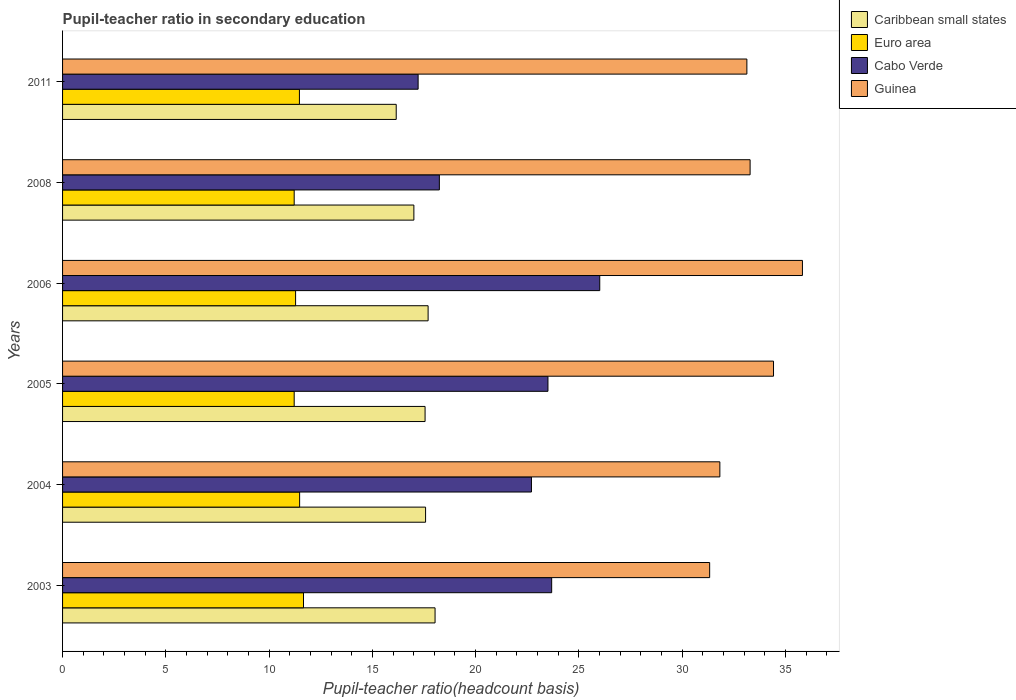How many different coloured bars are there?
Your answer should be very brief. 4. Are the number of bars on each tick of the Y-axis equal?
Make the answer very short. Yes. How many bars are there on the 1st tick from the top?
Offer a very short reply. 4. What is the pupil-teacher ratio in secondary education in Euro area in 2004?
Make the answer very short. 11.48. Across all years, what is the maximum pupil-teacher ratio in secondary education in Caribbean small states?
Offer a very short reply. 18.04. Across all years, what is the minimum pupil-teacher ratio in secondary education in Cabo Verde?
Ensure brevity in your answer.  17.22. In which year was the pupil-teacher ratio in secondary education in Guinea minimum?
Provide a short and direct response. 2003. What is the total pupil-teacher ratio in secondary education in Caribbean small states in the graph?
Your answer should be very brief. 104.04. What is the difference between the pupil-teacher ratio in secondary education in Guinea in 2003 and that in 2008?
Your response must be concise. -1.96. What is the difference between the pupil-teacher ratio in secondary education in Caribbean small states in 2005 and the pupil-teacher ratio in secondary education in Guinea in 2008?
Offer a terse response. -15.74. What is the average pupil-teacher ratio in secondary education in Guinea per year?
Provide a succinct answer. 33.31. In the year 2011, what is the difference between the pupil-teacher ratio in secondary education in Euro area and pupil-teacher ratio in secondary education in Guinea?
Give a very brief answer. -21.67. In how many years, is the pupil-teacher ratio in secondary education in Caribbean small states greater than 5 ?
Offer a terse response. 6. What is the ratio of the pupil-teacher ratio in secondary education in Guinea in 2003 to that in 2006?
Ensure brevity in your answer.  0.87. What is the difference between the highest and the second highest pupil-teacher ratio in secondary education in Euro area?
Your answer should be compact. 0.19. What is the difference between the highest and the lowest pupil-teacher ratio in secondary education in Guinea?
Make the answer very short. 4.49. In how many years, is the pupil-teacher ratio in secondary education in Guinea greater than the average pupil-teacher ratio in secondary education in Guinea taken over all years?
Provide a short and direct response. 2. Is the sum of the pupil-teacher ratio in secondary education in Guinea in 2003 and 2011 greater than the maximum pupil-teacher ratio in secondary education in Euro area across all years?
Your answer should be compact. Yes. What does the 4th bar from the top in 2011 represents?
Provide a succinct answer. Caribbean small states. What does the 3rd bar from the bottom in 2005 represents?
Provide a succinct answer. Cabo Verde. What is the difference between two consecutive major ticks on the X-axis?
Give a very brief answer. 5. Does the graph contain any zero values?
Provide a succinct answer. No. Where does the legend appear in the graph?
Give a very brief answer. Top right. What is the title of the graph?
Your answer should be compact. Pupil-teacher ratio in secondary education. What is the label or title of the X-axis?
Your answer should be very brief. Pupil-teacher ratio(headcount basis). What is the label or title of the Y-axis?
Offer a very short reply. Years. What is the Pupil-teacher ratio(headcount basis) in Caribbean small states in 2003?
Offer a very short reply. 18.04. What is the Pupil-teacher ratio(headcount basis) in Euro area in 2003?
Provide a succinct answer. 11.67. What is the Pupil-teacher ratio(headcount basis) of Cabo Verde in 2003?
Your answer should be very brief. 23.68. What is the Pupil-teacher ratio(headcount basis) in Guinea in 2003?
Give a very brief answer. 31.33. What is the Pupil-teacher ratio(headcount basis) of Caribbean small states in 2004?
Provide a succinct answer. 17.58. What is the Pupil-teacher ratio(headcount basis) of Euro area in 2004?
Make the answer very short. 11.48. What is the Pupil-teacher ratio(headcount basis) in Cabo Verde in 2004?
Keep it short and to the point. 22.7. What is the Pupil-teacher ratio(headcount basis) in Guinea in 2004?
Your answer should be compact. 31.83. What is the Pupil-teacher ratio(headcount basis) of Caribbean small states in 2005?
Your answer should be compact. 17.55. What is the Pupil-teacher ratio(headcount basis) of Euro area in 2005?
Your response must be concise. 11.22. What is the Pupil-teacher ratio(headcount basis) of Cabo Verde in 2005?
Your response must be concise. 23.5. What is the Pupil-teacher ratio(headcount basis) of Guinea in 2005?
Provide a succinct answer. 34.43. What is the Pupil-teacher ratio(headcount basis) in Caribbean small states in 2006?
Ensure brevity in your answer.  17.7. What is the Pupil-teacher ratio(headcount basis) of Euro area in 2006?
Keep it short and to the point. 11.28. What is the Pupil-teacher ratio(headcount basis) in Cabo Verde in 2006?
Your response must be concise. 26.01. What is the Pupil-teacher ratio(headcount basis) in Guinea in 2006?
Give a very brief answer. 35.83. What is the Pupil-teacher ratio(headcount basis) of Caribbean small states in 2008?
Your response must be concise. 17.01. What is the Pupil-teacher ratio(headcount basis) of Euro area in 2008?
Give a very brief answer. 11.22. What is the Pupil-teacher ratio(headcount basis) of Cabo Verde in 2008?
Keep it short and to the point. 18.25. What is the Pupil-teacher ratio(headcount basis) in Guinea in 2008?
Your answer should be very brief. 33.29. What is the Pupil-teacher ratio(headcount basis) in Caribbean small states in 2011?
Your response must be concise. 16.16. What is the Pupil-teacher ratio(headcount basis) of Euro area in 2011?
Provide a succinct answer. 11.47. What is the Pupil-teacher ratio(headcount basis) in Cabo Verde in 2011?
Make the answer very short. 17.22. What is the Pupil-teacher ratio(headcount basis) of Guinea in 2011?
Provide a succinct answer. 33.14. Across all years, what is the maximum Pupil-teacher ratio(headcount basis) of Caribbean small states?
Keep it short and to the point. 18.04. Across all years, what is the maximum Pupil-teacher ratio(headcount basis) of Euro area?
Keep it short and to the point. 11.67. Across all years, what is the maximum Pupil-teacher ratio(headcount basis) of Cabo Verde?
Provide a succinct answer. 26.01. Across all years, what is the maximum Pupil-teacher ratio(headcount basis) in Guinea?
Offer a terse response. 35.83. Across all years, what is the minimum Pupil-teacher ratio(headcount basis) of Caribbean small states?
Provide a succinct answer. 16.16. Across all years, what is the minimum Pupil-teacher ratio(headcount basis) in Euro area?
Offer a terse response. 11.22. Across all years, what is the minimum Pupil-teacher ratio(headcount basis) of Cabo Verde?
Make the answer very short. 17.22. Across all years, what is the minimum Pupil-teacher ratio(headcount basis) of Guinea?
Provide a succinct answer. 31.33. What is the total Pupil-teacher ratio(headcount basis) of Caribbean small states in the graph?
Your response must be concise. 104.04. What is the total Pupil-teacher ratio(headcount basis) of Euro area in the graph?
Keep it short and to the point. 68.33. What is the total Pupil-teacher ratio(headcount basis) in Cabo Verde in the graph?
Your response must be concise. 131.36. What is the total Pupil-teacher ratio(headcount basis) of Guinea in the graph?
Provide a short and direct response. 199.84. What is the difference between the Pupil-teacher ratio(headcount basis) in Caribbean small states in 2003 and that in 2004?
Keep it short and to the point. 0.46. What is the difference between the Pupil-teacher ratio(headcount basis) in Euro area in 2003 and that in 2004?
Make the answer very short. 0.19. What is the difference between the Pupil-teacher ratio(headcount basis) in Cabo Verde in 2003 and that in 2004?
Provide a short and direct response. 0.98. What is the difference between the Pupil-teacher ratio(headcount basis) of Guinea in 2003 and that in 2004?
Provide a succinct answer. -0.49. What is the difference between the Pupil-teacher ratio(headcount basis) in Caribbean small states in 2003 and that in 2005?
Provide a short and direct response. 0.48. What is the difference between the Pupil-teacher ratio(headcount basis) in Euro area in 2003 and that in 2005?
Make the answer very short. 0.45. What is the difference between the Pupil-teacher ratio(headcount basis) of Cabo Verde in 2003 and that in 2005?
Make the answer very short. 0.18. What is the difference between the Pupil-teacher ratio(headcount basis) of Guinea in 2003 and that in 2005?
Your answer should be very brief. -3.09. What is the difference between the Pupil-teacher ratio(headcount basis) in Caribbean small states in 2003 and that in 2006?
Offer a terse response. 0.34. What is the difference between the Pupil-teacher ratio(headcount basis) in Euro area in 2003 and that in 2006?
Make the answer very short. 0.38. What is the difference between the Pupil-teacher ratio(headcount basis) of Cabo Verde in 2003 and that in 2006?
Offer a very short reply. -2.33. What is the difference between the Pupil-teacher ratio(headcount basis) in Guinea in 2003 and that in 2006?
Ensure brevity in your answer.  -4.49. What is the difference between the Pupil-teacher ratio(headcount basis) of Caribbean small states in 2003 and that in 2008?
Provide a succinct answer. 1.03. What is the difference between the Pupil-teacher ratio(headcount basis) in Euro area in 2003 and that in 2008?
Provide a short and direct response. 0.45. What is the difference between the Pupil-teacher ratio(headcount basis) of Cabo Verde in 2003 and that in 2008?
Provide a short and direct response. 5.44. What is the difference between the Pupil-teacher ratio(headcount basis) of Guinea in 2003 and that in 2008?
Your answer should be compact. -1.96. What is the difference between the Pupil-teacher ratio(headcount basis) of Caribbean small states in 2003 and that in 2011?
Your answer should be very brief. 1.88. What is the difference between the Pupil-teacher ratio(headcount basis) in Euro area in 2003 and that in 2011?
Make the answer very short. 0.2. What is the difference between the Pupil-teacher ratio(headcount basis) of Cabo Verde in 2003 and that in 2011?
Provide a short and direct response. 6.47. What is the difference between the Pupil-teacher ratio(headcount basis) in Guinea in 2003 and that in 2011?
Your response must be concise. -1.8. What is the difference between the Pupil-teacher ratio(headcount basis) of Caribbean small states in 2004 and that in 2005?
Provide a short and direct response. 0.02. What is the difference between the Pupil-teacher ratio(headcount basis) in Euro area in 2004 and that in 2005?
Make the answer very short. 0.26. What is the difference between the Pupil-teacher ratio(headcount basis) in Cabo Verde in 2004 and that in 2005?
Provide a short and direct response. -0.8. What is the difference between the Pupil-teacher ratio(headcount basis) in Guinea in 2004 and that in 2005?
Provide a succinct answer. -2.6. What is the difference between the Pupil-teacher ratio(headcount basis) in Caribbean small states in 2004 and that in 2006?
Your response must be concise. -0.12. What is the difference between the Pupil-teacher ratio(headcount basis) of Euro area in 2004 and that in 2006?
Provide a short and direct response. 0.2. What is the difference between the Pupil-teacher ratio(headcount basis) of Cabo Verde in 2004 and that in 2006?
Provide a succinct answer. -3.31. What is the difference between the Pupil-teacher ratio(headcount basis) of Guinea in 2004 and that in 2006?
Offer a very short reply. -4. What is the difference between the Pupil-teacher ratio(headcount basis) of Caribbean small states in 2004 and that in 2008?
Your response must be concise. 0.57. What is the difference between the Pupil-teacher ratio(headcount basis) in Euro area in 2004 and that in 2008?
Ensure brevity in your answer.  0.26. What is the difference between the Pupil-teacher ratio(headcount basis) in Cabo Verde in 2004 and that in 2008?
Your response must be concise. 4.46. What is the difference between the Pupil-teacher ratio(headcount basis) of Guinea in 2004 and that in 2008?
Make the answer very short. -1.46. What is the difference between the Pupil-teacher ratio(headcount basis) of Caribbean small states in 2004 and that in 2011?
Give a very brief answer. 1.42. What is the difference between the Pupil-teacher ratio(headcount basis) in Euro area in 2004 and that in 2011?
Give a very brief answer. 0.01. What is the difference between the Pupil-teacher ratio(headcount basis) in Cabo Verde in 2004 and that in 2011?
Offer a terse response. 5.49. What is the difference between the Pupil-teacher ratio(headcount basis) in Guinea in 2004 and that in 2011?
Your answer should be very brief. -1.31. What is the difference between the Pupil-teacher ratio(headcount basis) of Caribbean small states in 2005 and that in 2006?
Ensure brevity in your answer.  -0.15. What is the difference between the Pupil-teacher ratio(headcount basis) of Euro area in 2005 and that in 2006?
Your answer should be compact. -0.07. What is the difference between the Pupil-teacher ratio(headcount basis) of Cabo Verde in 2005 and that in 2006?
Your response must be concise. -2.51. What is the difference between the Pupil-teacher ratio(headcount basis) in Guinea in 2005 and that in 2006?
Provide a short and direct response. -1.4. What is the difference between the Pupil-teacher ratio(headcount basis) in Caribbean small states in 2005 and that in 2008?
Make the answer very short. 0.54. What is the difference between the Pupil-teacher ratio(headcount basis) in Euro area in 2005 and that in 2008?
Your answer should be compact. 0. What is the difference between the Pupil-teacher ratio(headcount basis) of Cabo Verde in 2005 and that in 2008?
Keep it short and to the point. 5.26. What is the difference between the Pupil-teacher ratio(headcount basis) in Guinea in 2005 and that in 2008?
Ensure brevity in your answer.  1.13. What is the difference between the Pupil-teacher ratio(headcount basis) in Caribbean small states in 2005 and that in 2011?
Your answer should be very brief. 1.4. What is the difference between the Pupil-teacher ratio(headcount basis) of Euro area in 2005 and that in 2011?
Your response must be concise. -0.25. What is the difference between the Pupil-teacher ratio(headcount basis) of Cabo Verde in 2005 and that in 2011?
Offer a very short reply. 6.29. What is the difference between the Pupil-teacher ratio(headcount basis) in Guinea in 2005 and that in 2011?
Your answer should be very brief. 1.29. What is the difference between the Pupil-teacher ratio(headcount basis) of Caribbean small states in 2006 and that in 2008?
Offer a very short reply. 0.69. What is the difference between the Pupil-teacher ratio(headcount basis) of Euro area in 2006 and that in 2008?
Your response must be concise. 0.07. What is the difference between the Pupil-teacher ratio(headcount basis) of Cabo Verde in 2006 and that in 2008?
Give a very brief answer. 7.77. What is the difference between the Pupil-teacher ratio(headcount basis) in Guinea in 2006 and that in 2008?
Provide a succinct answer. 2.53. What is the difference between the Pupil-teacher ratio(headcount basis) in Caribbean small states in 2006 and that in 2011?
Provide a succinct answer. 1.54. What is the difference between the Pupil-teacher ratio(headcount basis) in Euro area in 2006 and that in 2011?
Keep it short and to the point. -0.19. What is the difference between the Pupil-teacher ratio(headcount basis) of Cabo Verde in 2006 and that in 2011?
Make the answer very short. 8.79. What is the difference between the Pupil-teacher ratio(headcount basis) in Guinea in 2006 and that in 2011?
Your answer should be compact. 2.69. What is the difference between the Pupil-teacher ratio(headcount basis) of Caribbean small states in 2008 and that in 2011?
Provide a short and direct response. 0.86. What is the difference between the Pupil-teacher ratio(headcount basis) in Euro area in 2008 and that in 2011?
Give a very brief answer. -0.25. What is the difference between the Pupil-teacher ratio(headcount basis) in Cabo Verde in 2008 and that in 2011?
Keep it short and to the point. 1.03. What is the difference between the Pupil-teacher ratio(headcount basis) in Guinea in 2008 and that in 2011?
Make the answer very short. 0.16. What is the difference between the Pupil-teacher ratio(headcount basis) of Caribbean small states in 2003 and the Pupil-teacher ratio(headcount basis) of Euro area in 2004?
Ensure brevity in your answer.  6.56. What is the difference between the Pupil-teacher ratio(headcount basis) of Caribbean small states in 2003 and the Pupil-teacher ratio(headcount basis) of Cabo Verde in 2004?
Ensure brevity in your answer.  -4.67. What is the difference between the Pupil-teacher ratio(headcount basis) of Caribbean small states in 2003 and the Pupil-teacher ratio(headcount basis) of Guinea in 2004?
Provide a short and direct response. -13.79. What is the difference between the Pupil-teacher ratio(headcount basis) in Euro area in 2003 and the Pupil-teacher ratio(headcount basis) in Cabo Verde in 2004?
Give a very brief answer. -11.04. What is the difference between the Pupil-teacher ratio(headcount basis) of Euro area in 2003 and the Pupil-teacher ratio(headcount basis) of Guinea in 2004?
Provide a succinct answer. -20.16. What is the difference between the Pupil-teacher ratio(headcount basis) in Cabo Verde in 2003 and the Pupil-teacher ratio(headcount basis) in Guinea in 2004?
Offer a terse response. -8.14. What is the difference between the Pupil-teacher ratio(headcount basis) in Caribbean small states in 2003 and the Pupil-teacher ratio(headcount basis) in Euro area in 2005?
Keep it short and to the point. 6.82. What is the difference between the Pupil-teacher ratio(headcount basis) in Caribbean small states in 2003 and the Pupil-teacher ratio(headcount basis) in Cabo Verde in 2005?
Provide a short and direct response. -5.47. What is the difference between the Pupil-teacher ratio(headcount basis) in Caribbean small states in 2003 and the Pupil-teacher ratio(headcount basis) in Guinea in 2005?
Make the answer very short. -16.39. What is the difference between the Pupil-teacher ratio(headcount basis) in Euro area in 2003 and the Pupil-teacher ratio(headcount basis) in Cabo Verde in 2005?
Provide a short and direct response. -11.84. What is the difference between the Pupil-teacher ratio(headcount basis) in Euro area in 2003 and the Pupil-teacher ratio(headcount basis) in Guinea in 2005?
Your response must be concise. -22.76. What is the difference between the Pupil-teacher ratio(headcount basis) in Cabo Verde in 2003 and the Pupil-teacher ratio(headcount basis) in Guinea in 2005?
Your response must be concise. -10.74. What is the difference between the Pupil-teacher ratio(headcount basis) in Caribbean small states in 2003 and the Pupil-teacher ratio(headcount basis) in Euro area in 2006?
Your answer should be very brief. 6.75. What is the difference between the Pupil-teacher ratio(headcount basis) of Caribbean small states in 2003 and the Pupil-teacher ratio(headcount basis) of Cabo Verde in 2006?
Ensure brevity in your answer.  -7.97. What is the difference between the Pupil-teacher ratio(headcount basis) of Caribbean small states in 2003 and the Pupil-teacher ratio(headcount basis) of Guinea in 2006?
Your response must be concise. -17.79. What is the difference between the Pupil-teacher ratio(headcount basis) in Euro area in 2003 and the Pupil-teacher ratio(headcount basis) in Cabo Verde in 2006?
Your response must be concise. -14.34. What is the difference between the Pupil-teacher ratio(headcount basis) of Euro area in 2003 and the Pupil-teacher ratio(headcount basis) of Guinea in 2006?
Ensure brevity in your answer.  -24.16. What is the difference between the Pupil-teacher ratio(headcount basis) of Cabo Verde in 2003 and the Pupil-teacher ratio(headcount basis) of Guinea in 2006?
Offer a very short reply. -12.14. What is the difference between the Pupil-teacher ratio(headcount basis) in Caribbean small states in 2003 and the Pupil-teacher ratio(headcount basis) in Euro area in 2008?
Give a very brief answer. 6.82. What is the difference between the Pupil-teacher ratio(headcount basis) of Caribbean small states in 2003 and the Pupil-teacher ratio(headcount basis) of Cabo Verde in 2008?
Your answer should be very brief. -0.21. What is the difference between the Pupil-teacher ratio(headcount basis) in Caribbean small states in 2003 and the Pupil-teacher ratio(headcount basis) in Guinea in 2008?
Give a very brief answer. -15.26. What is the difference between the Pupil-teacher ratio(headcount basis) in Euro area in 2003 and the Pupil-teacher ratio(headcount basis) in Cabo Verde in 2008?
Provide a succinct answer. -6.58. What is the difference between the Pupil-teacher ratio(headcount basis) of Euro area in 2003 and the Pupil-teacher ratio(headcount basis) of Guinea in 2008?
Give a very brief answer. -21.63. What is the difference between the Pupil-teacher ratio(headcount basis) of Cabo Verde in 2003 and the Pupil-teacher ratio(headcount basis) of Guinea in 2008?
Your response must be concise. -9.61. What is the difference between the Pupil-teacher ratio(headcount basis) in Caribbean small states in 2003 and the Pupil-teacher ratio(headcount basis) in Euro area in 2011?
Your response must be concise. 6.57. What is the difference between the Pupil-teacher ratio(headcount basis) in Caribbean small states in 2003 and the Pupil-teacher ratio(headcount basis) in Cabo Verde in 2011?
Your answer should be compact. 0.82. What is the difference between the Pupil-teacher ratio(headcount basis) of Caribbean small states in 2003 and the Pupil-teacher ratio(headcount basis) of Guinea in 2011?
Ensure brevity in your answer.  -15.1. What is the difference between the Pupil-teacher ratio(headcount basis) in Euro area in 2003 and the Pupil-teacher ratio(headcount basis) in Cabo Verde in 2011?
Make the answer very short. -5.55. What is the difference between the Pupil-teacher ratio(headcount basis) in Euro area in 2003 and the Pupil-teacher ratio(headcount basis) in Guinea in 2011?
Your response must be concise. -21.47. What is the difference between the Pupil-teacher ratio(headcount basis) of Cabo Verde in 2003 and the Pupil-teacher ratio(headcount basis) of Guinea in 2011?
Give a very brief answer. -9.45. What is the difference between the Pupil-teacher ratio(headcount basis) in Caribbean small states in 2004 and the Pupil-teacher ratio(headcount basis) in Euro area in 2005?
Offer a terse response. 6.36. What is the difference between the Pupil-teacher ratio(headcount basis) of Caribbean small states in 2004 and the Pupil-teacher ratio(headcount basis) of Cabo Verde in 2005?
Ensure brevity in your answer.  -5.93. What is the difference between the Pupil-teacher ratio(headcount basis) of Caribbean small states in 2004 and the Pupil-teacher ratio(headcount basis) of Guinea in 2005?
Your answer should be very brief. -16.85. What is the difference between the Pupil-teacher ratio(headcount basis) in Euro area in 2004 and the Pupil-teacher ratio(headcount basis) in Cabo Verde in 2005?
Offer a terse response. -12.02. What is the difference between the Pupil-teacher ratio(headcount basis) of Euro area in 2004 and the Pupil-teacher ratio(headcount basis) of Guinea in 2005?
Provide a succinct answer. -22.95. What is the difference between the Pupil-teacher ratio(headcount basis) in Cabo Verde in 2004 and the Pupil-teacher ratio(headcount basis) in Guinea in 2005?
Offer a very short reply. -11.72. What is the difference between the Pupil-teacher ratio(headcount basis) in Caribbean small states in 2004 and the Pupil-teacher ratio(headcount basis) in Euro area in 2006?
Give a very brief answer. 6.29. What is the difference between the Pupil-teacher ratio(headcount basis) in Caribbean small states in 2004 and the Pupil-teacher ratio(headcount basis) in Cabo Verde in 2006?
Ensure brevity in your answer.  -8.43. What is the difference between the Pupil-teacher ratio(headcount basis) of Caribbean small states in 2004 and the Pupil-teacher ratio(headcount basis) of Guinea in 2006?
Your answer should be very brief. -18.25. What is the difference between the Pupil-teacher ratio(headcount basis) of Euro area in 2004 and the Pupil-teacher ratio(headcount basis) of Cabo Verde in 2006?
Make the answer very short. -14.53. What is the difference between the Pupil-teacher ratio(headcount basis) of Euro area in 2004 and the Pupil-teacher ratio(headcount basis) of Guinea in 2006?
Keep it short and to the point. -24.35. What is the difference between the Pupil-teacher ratio(headcount basis) in Cabo Verde in 2004 and the Pupil-teacher ratio(headcount basis) in Guinea in 2006?
Keep it short and to the point. -13.12. What is the difference between the Pupil-teacher ratio(headcount basis) of Caribbean small states in 2004 and the Pupil-teacher ratio(headcount basis) of Euro area in 2008?
Your response must be concise. 6.36. What is the difference between the Pupil-teacher ratio(headcount basis) of Caribbean small states in 2004 and the Pupil-teacher ratio(headcount basis) of Cabo Verde in 2008?
Your answer should be compact. -0.67. What is the difference between the Pupil-teacher ratio(headcount basis) in Caribbean small states in 2004 and the Pupil-teacher ratio(headcount basis) in Guinea in 2008?
Give a very brief answer. -15.71. What is the difference between the Pupil-teacher ratio(headcount basis) in Euro area in 2004 and the Pupil-teacher ratio(headcount basis) in Cabo Verde in 2008?
Offer a very short reply. -6.77. What is the difference between the Pupil-teacher ratio(headcount basis) in Euro area in 2004 and the Pupil-teacher ratio(headcount basis) in Guinea in 2008?
Ensure brevity in your answer.  -21.81. What is the difference between the Pupil-teacher ratio(headcount basis) in Cabo Verde in 2004 and the Pupil-teacher ratio(headcount basis) in Guinea in 2008?
Offer a terse response. -10.59. What is the difference between the Pupil-teacher ratio(headcount basis) of Caribbean small states in 2004 and the Pupil-teacher ratio(headcount basis) of Euro area in 2011?
Provide a short and direct response. 6.11. What is the difference between the Pupil-teacher ratio(headcount basis) of Caribbean small states in 2004 and the Pupil-teacher ratio(headcount basis) of Cabo Verde in 2011?
Provide a short and direct response. 0.36. What is the difference between the Pupil-teacher ratio(headcount basis) of Caribbean small states in 2004 and the Pupil-teacher ratio(headcount basis) of Guinea in 2011?
Provide a succinct answer. -15.56. What is the difference between the Pupil-teacher ratio(headcount basis) in Euro area in 2004 and the Pupil-teacher ratio(headcount basis) in Cabo Verde in 2011?
Offer a very short reply. -5.74. What is the difference between the Pupil-teacher ratio(headcount basis) of Euro area in 2004 and the Pupil-teacher ratio(headcount basis) of Guinea in 2011?
Provide a short and direct response. -21.66. What is the difference between the Pupil-teacher ratio(headcount basis) of Cabo Verde in 2004 and the Pupil-teacher ratio(headcount basis) of Guinea in 2011?
Your answer should be compact. -10.43. What is the difference between the Pupil-teacher ratio(headcount basis) in Caribbean small states in 2005 and the Pupil-teacher ratio(headcount basis) in Euro area in 2006?
Give a very brief answer. 6.27. What is the difference between the Pupil-teacher ratio(headcount basis) of Caribbean small states in 2005 and the Pupil-teacher ratio(headcount basis) of Cabo Verde in 2006?
Ensure brevity in your answer.  -8.46. What is the difference between the Pupil-teacher ratio(headcount basis) in Caribbean small states in 2005 and the Pupil-teacher ratio(headcount basis) in Guinea in 2006?
Offer a very short reply. -18.27. What is the difference between the Pupil-teacher ratio(headcount basis) in Euro area in 2005 and the Pupil-teacher ratio(headcount basis) in Cabo Verde in 2006?
Ensure brevity in your answer.  -14.8. What is the difference between the Pupil-teacher ratio(headcount basis) in Euro area in 2005 and the Pupil-teacher ratio(headcount basis) in Guinea in 2006?
Give a very brief answer. -24.61. What is the difference between the Pupil-teacher ratio(headcount basis) in Cabo Verde in 2005 and the Pupil-teacher ratio(headcount basis) in Guinea in 2006?
Give a very brief answer. -12.32. What is the difference between the Pupil-teacher ratio(headcount basis) in Caribbean small states in 2005 and the Pupil-teacher ratio(headcount basis) in Euro area in 2008?
Your response must be concise. 6.34. What is the difference between the Pupil-teacher ratio(headcount basis) of Caribbean small states in 2005 and the Pupil-teacher ratio(headcount basis) of Cabo Verde in 2008?
Offer a very short reply. -0.69. What is the difference between the Pupil-teacher ratio(headcount basis) in Caribbean small states in 2005 and the Pupil-teacher ratio(headcount basis) in Guinea in 2008?
Your response must be concise. -15.74. What is the difference between the Pupil-teacher ratio(headcount basis) of Euro area in 2005 and the Pupil-teacher ratio(headcount basis) of Cabo Verde in 2008?
Offer a terse response. -7.03. What is the difference between the Pupil-teacher ratio(headcount basis) in Euro area in 2005 and the Pupil-teacher ratio(headcount basis) in Guinea in 2008?
Offer a terse response. -22.08. What is the difference between the Pupil-teacher ratio(headcount basis) of Cabo Verde in 2005 and the Pupil-teacher ratio(headcount basis) of Guinea in 2008?
Ensure brevity in your answer.  -9.79. What is the difference between the Pupil-teacher ratio(headcount basis) of Caribbean small states in 2005 and the Pupil-teacher ratio(headcount basis) of Euro area in 2011?
Make the answer very short. 6.08. What is the difference between the Pupil-teacher ratio(headcount basis) of Caribbean small states in 2005 and the Pupil-teacher ratio(headcount basis) of Cabo Verde in 2011?
Your answer should be very brief. 0.34. What is the difference between the Pupil-teacher ratio(headcount basis) in Caribbean small states in 2005 and the Pupil-teacher ratio(headcount basis) in Guinea in 2011?
Provide a short and direct response. -15.58. What is the difference between the Pupil-teacher ratio(headcount basis) in Euro area in 2005 and the Pupil-teacher ratio(headcount basis) in Cabo Verde in 2011?
Keep it short and to the point. -6. What is the difference between the Pupil-teacher ratio(headcount basis) in Euro area in 2005 and the Pupil-teacher ratio(headcount basis) in Guinea in 2011?
Make the answer very short. -21.92. What is the difference between the Pupil-teacher ratio(headcount basis) of Cabo Verde in 2005 and the Pupil-teacher ratio(headcount basis) of Guinea in 2011?
Make the answer very short. -9.63. What is the difference between the Pupil-teacher ratio(headcount basis) in Caribbean small states in 2006 and the Pupil-teacher ratio(headcount basis) in Euro area in 2008?
Offer a very short reply. 6.49. What is the difference between the Pupil-teacher ratio(headcount basis) in Caribbean small states in 2006 and the Pupil-teacher ratio(headcount basis) in Cabo Verde in 2008?
Your answer should be very brief. -0.54. What is the difference between the Pupil-teacher ratio(headcount basis) in Caribbean small states in 2006 and the Pupil-teacher ratio(headcount basis) in Guinea in 2008?
Make the answer very short. -15.59. What is the difference between the Pupil-teacher ratio(headcount basis) in Euro area in 2006 and the Pupil-teacher ratio(headcount basis) in Cabo Verde in 2008?
Offer a very short reply. -6.96. What is the difference between the Pupil-teacher ratio(headcount basis) of Euro area in 2006 and the Pupil-teacher ratio(headcount basis) of Guinea in 2008?
Your response must be concise. -22.01. What is the difference between the Pupil-teacher ratio(headcount basis) of Cabo Verde in 2006 and the Pupil-teacher ratio(headcount basis) of Guinea in 2008?
Provide a short and direct response. -7.28. What is the difference between the Pupil-teacher ratio(headcount basis) of Caribbean small states in 2006 and the Pupil-teacher ratio(headcount basis) of Euro area in 2011?
Keep it short and to the point. 6.23. What is the difference between the Pupil-teacher ratio(headcount basis) of Caribbean small states in 2006 and the Pupil-teacher ratio(headcount basis) of Cabo Verde in 2011?
Ensure brevity in your answer.  0.48. What is the difference between the Pupil-teacher ratio(headcount basis) of Caribbean small states in 2006 and the Pupil-teacher ratio(headcount basis) of Guinea in 2011?
Your response must be concise. -15.44. What is the difference between the Pupil-teacher ratio(headcount basis) of Euro area in 2006 and the Pupil-teacher ratio(headcount basis) of Cabo Verde in 2011?
Provide a succinct answer. -5.93. What is the difference between the Pupil-teacher ratio(headcount basis) of Euro area in 2006 and the Pupil-teacher ratio(headcount basis) of Guinea in 2011?
Make the answer very short. -21.85. What is the difference between the Pupil-teacher ratio(headcount basis) of Cabo Verde in 2006 and the Pupil-teacher ratio(headcount basis) of Guinea in 2011?
Your answer should be very brief. -7.12. What is the difference between the Pupil-teacher ratio(headcount basis) in Caribbean small states in 2008 and the Pupil-teacher ratio(headcount basis) in Euro area in 2011?
Give a very brief answer. 5.54. What is the difference between the Pupil-teacher ratio(headcount basis) in Caribbean small states in 2008 and the Pupil-teacher ratio(headcount basis) in Cabo Verde in 2011?
Give a very brief answer. -0.21. What is the difference between the Pupil-teacher ratio(headcount basis) of Caribbean small states in 2008 and the Pupil-teacher ratio(headcount basis) of Guinea in 2011?
Your answer should be very brief. -16.12. What is the difference between the Pupil-teacher ratio(headcount basis) of Euro area in 2008 and the Pupil-teacher ratio(headcount basis) of Cabo Verde in 2011?
Ensure brevity in your answer.  -6. What is the difference between the Pupil-teacher ratio(headcount basis) in Euro area in 2008 and the Pupil-teacher ratio(headcount basis) in Guinea in 2011?
Your response must be concise. -21.92. What is the difference between the Pupil-teacher ratio(headcount basis) of Cabo Verde in 2008 and the Pupil-teacher ratio(headcount basis) of Guinea in 2011?
Offer a very short reply. -14.89. What is the average Pupil-teacher ratio(headcount basis) in Caribbean small states per year?
Provide a succinct answer. 17.34. What is the average Pupil-teacher ratio(headcount basis) in Euro area per year?
Keep it short and to the point. 11.39. What is the average Pupil-teacher ratio(headcount basis) in Cabo Verde per year?
Provide a succinct answer. 21.89. What is the average Pupil-teacher ratio(headcount basis) in Guinea per year?
Keep it short and to the point. 33.31. In the year 2003, what is the difference between the Pupil-teacher ratio(headcount basis) of Caribbean small states and Pupil-teacher ratio(headcount basis) of Euro area?
Provide a short and direct response. 6.37. In the year 2003, what is the difference between the Pupil-teacher ratio(headcount basis) in Caribbean small states and Pupil-teacher ratio(headcount basis) in Cabo Verde?
Provide a succinct answer. -5.65. In the year 2003, what is the difference between the Pupil-teacher ratio(headcount basis) in Caribbean small states and Pupil-teacher ratio(headcount basis) in Guinea?
Make the answer very short. -13.3. In the year 2003, what is the difference between the Pupil-teacher ratio(headcount basis) of Euro area and Pupil-teacher ratio(headcount basis) of Cabo Verde?
Your answer should be very brief. -12.02. In the year 2003, what is the difference between the Pupil-teacher ratio(headcount basis) of Euro area and Pupil-teacher ratio(headcount basis) of Guinea?
Your response must be concise. -19.67. In the year 2003, what is the difference between the Pupil-teacher ratio(headcount basis) of Cabo Verde and Pupil-teacher ratio(headcount basis) of Guinea?
Ensure brevity in your answer.  -7.65. In the year 2004, what is the difference between the Pupil-teacher ratio(headcount basis) of Caribbean small states and Pupil-teacher ratio(headcount basis) of Euro area?
Your answer should be compact. 6.1. In the year 2004, what is the difference between the Pupil-teacher ratio(headcount basis) of Caribbean small states and Pupil-teacher ratio(headcount basis) of Cabo Verde?
Provide a short and direct response. -5.13. In the year 2004, what is the difference between the Pupil-teacher ratio(headcount basis) of Caribbean small states and Pupil-teacher ratio(headcount basis) of Guinea?
Give a very brief answer. -14.25. In the year 2004, what is the difference between the Pupil-teacher ratio(headcount basis) in Euro area and Pupil-teacher ratio(headcount basis) in Cabo Verde?
Ensure brevity in your answer.  -11.23. In the year 2004, what is the difference between the Pupil-teacher ratio(headcount basis) of Euro area and Pupil-teacher ratio(headcount basis) of Guinea?
Your answer should be compact. -20.35. In the year 2004, what is the difference between the Pupil-teacher ratio(headcount basis) in Cabo Verde and Pupil-teacher ratio(headcount basis) in Guinea?
Your answer should be very brief. -9.12. In the year 2005, what is the difference between the Pupil-teacher ratio(headcount basis) of Caribbean small states and Pupil-teacher ratio(headcount basis) of Euro area?
Provide a succinct answer. 6.34. In the year 2005, what is the difference between the Pupil-teacher ratio(headcount basis) of Caribbean small states and Pupil-teacher ratio(headcount basis) of Cabo Verde?
Provide a succinct answer. -5.95. In the year 2005, what is the difference between the Pupil-teacher ratio(headcount basis) in Caribbean small states and Pupil-teacher ratio(headcount basis) in Guinea?
Offer a very short reply. -16.87. In the year 2005, what is the difference between the Pupil-teacher ratio(headcount basis) in Euro area and Pupil-teacher ratio(headcount basis) in Cabo Verde?
Your answer should be compact. -12.29. In the year 2005, what is the difference between the Pupil-teacher ratio(headcount basis) of Euro area and Pupil-teacher ratio(headcount basis) of Guinea?
Your answer should be compact. -23.21. In the year 2005, what is the difference between the Pupil-teacher ratio(headcount basis) in Cabo Verde and Pupil-teacher ratio(headcount basis) in Guinea?
Make the answer very short. -10.92. In the year 2006, what is the difference between the Pupil-teacher ratio(headcount basis) in Caribbean small states and Pupil-teacher ratio(headcount basis) in Euro area?
Your response must be concise. 6.42. In the year 2006, what is the difference between the Pupil-teacher ratio(headcount basis) in Caribbean small states and Pupil-teacher ratio(headcount basis) in Cabo Verde?
Make the answer very short. -8.31. In the year 2006, what is the difference between the Pupil-teacher ratio(headcount basis) in Caribbean small states and Pupil-teacher ratio(headcount basis) in Guinea?
Make the answer very short. -18.13. In the year 2006, what is the difference between the Pupil-teacher ratio(headcount basis) in Euro area and Pupil-teacher ratio(headcount basis) in Cabo Verde?
Provide a short and direct response. -14.73. In the year 2006, what is the difference between the Pupil-teacher ratio(headcount basis) of Euro area and Pupil-teacher ratio(headcount basis) of Guinea?
Provide a succinct answer. -24.54. In the year 2006, what is the difference between the Pupil-teacher ratio(headcount basis) of Cabo Verde and Pupil-teacher ratio(headcount basis) of Guinea?
Your response must be concise. -9.81. In the year 2008, what is the difference between the Pupil-teacher ratio(headcount basis) of Caribbean small states and Pupil-teacher ratio(headcount basis) of Euro area?
Your response must be concise. 5.8. In the year 2008, what is the difference between the Pupil-teacher ratio(headcount basis) of Caribbean small states and Pupil-teacher ratio(headcount basis) of Cabo Verde?
Give a very brief answer. -1.23. In the year 2008, what is the difference between the Pupil-teacher ratio(headcount basis) in Caribbean small states and Pupil-teacher ratio(headcount basis) in Guinea?
Make the answer very short. -16.28. In the year 2008, what is the difference between the Pupil-teacher ratio(headcount basis) of Euro area and Pupil-teacher ratio(headcount basis) of Cabo Verde?
Your response must be concise. -7.03. In the year 2008, what is the difference between the Pupil-teacher ratio(headcount basis) in Euro area and Pupil-teacher ratio(headcount basis) in Guinea?
Give a very brief answer. -22.08. In the year 2008, what is the difference between the Pupil-teacher ratio(headcount basis) of Cabo Verde and Pupil-teacher ratio(headcount basis) of Guinea?
Offer a terse response. -15.05. In the year 2011, what is the difference between the Pupil-teacher ratio(headcount basis) in Caribbean small states and Pupil-teacher ratio(headcount basis) in Euro area?
Offer a terse response. 4.69. In the year 2011, what is the difference between the Pupil-teacher ratio(headcount basis) of Caribbean small states and Pupil-teacher ratio(headcount basis) of Cabo Verde?
Offer a terse response. -1.06. In the year 2011, what is the difference between the Pupil-teacher ratio(headcount basis) of Caribbean small states and Pupil-teacher ratio(headcount basis) of Guinea?
Make the answer very short. -16.98. In the year 2011, what is the difference between the Pupil-teacher ratio(headcount basis) in Euro area and Pupil-teacher ratio(headcount basis) in Cabo Verde?
Your answer should be very brief. -5.75. In the year 2011, what is the difference between the Pupil-teacher ratio(headcount basis) of Euro area and Pupil-teacher ratio(headcount basis) of Guinea?
Make the answer very short. -21.67. In the year 2011, what is the difference between the Pupil-teacher ratio(headcount basis) in Cabo Verde and Pupil-teacher ratio(headcount basis) in Guinea?
Your response must be concise. -15.92. What is the ratio of the Pupil-teacher ratio(headcount basis) of Caribbean small states in 2003 to that in 2004?
Make the answer very short. 1.03. What is the ratio of the Pupil-teacher ratio(headcount basis) in Euro area in 2003 to that in 2004?
Your answer should be very brief. 1.02. What is the ratio of the Pupil-teacher ratio(headcount basis) of Cabo Verde in 2003 to that in 2004?
Ensure brevity in your answer.  1.04. What is the ratio of the Pupil-teacher ratio(headcount basis) of Guinea in 2003 to that in 2004?
Keep it short and to the point. 0.98. What is the ratio of the Pupil-teacher ratio(headcount basis) of Caribbean small states in 2003 to that in 2005?
Provide a succinct answer. 1.03. What is the ratio of the Pupil-teacher ratio(headcount basis) in Euro area in 2003 to that in 2005?
Provide a short and direct response. 1.04. What is the ratio of the Pupil-teacher ratio(headcount basis) in Cabo Verde in 2003 to that in 2005?
Make the answer very short. 1.01. What is the ratio of the Pupil-teacher ratio(headcount basis) in Guinea in 2003 to that in 2005?
Your answer should be compact. 0.91. What is the ratio of the Pupil-teacher ratio(headcount basis) in Euro area in 2003 to that in 2006?
Ensure brevity in your answer.  1.03. What is the ratio of the Pupil-teacher ratio(headcount basis) of Cabo Verde in 2003 to that in 2006?
Your answer should be compact. 0.91. What is the ratio of the Pupil-teacher ratio(headcount basis) in Guinea in 2003 to that in 2006?
Make the answer very short. 0.87. What is the ratio of the Pupil-teacher ratio(headcount basis) in Caribbean small states in 2003 to that in 2008?
Ensure brevity in your answer.  1.06. What is the ratio of the Pupil-teacher ratio(headcount basis) in Euro area in 2003 to that in 2008?
Your answer should be very brief. 1.04. What is the ratio of the Pupil-teacher ratio(headcount basis) in Cabo Verde in 2003 to that in 2008?
Give a very brief answer. 1.3. What is the ratio of the Pupil-teacher ratio(headcount basis) of Guinea in 2003 to that in 2008?
Make the answer very short. 0.94. What is the ratio of the Pupil-teacher ratio(headcount basis) of Caribbean small states in 2003 to that in 2011?
Make the answer very short. 1.12. What is the ratio of the Pupil-teacher ratio(headcount basis) in Euro area in 2003 to that in 2011?
Your response must be concise. 1.02. What is the ratio of the Pupil-teacher ratio(headcount basis) of Cabo Verde in 2003 to that in 2011?
Make the answer very short. 1.38. What is the ratio of the Pupil-teacher ratio(headcount basis) of Guinea in 2003 to that in 2011?
Give a very brief answer. 0.95. What is the ratio of the Pupil-teacher ratio(headcount basis) of Euro area in 2004 to that in 2005?
Provide a succinct answer. 1.02. What is the ratio of the Pupil-teacher ratio(headcount basis) in Cabo Verde in 2004 to that in 2005?
Your answer should be very brief. 0.97. What is the ratio of the Pupil-teacher ratio(headcount basis) of Guinea in 2004 to that in 2005?
Provide a short and direct response. 0.92. What is the ratio of the Pupil-teacher ratio(headcount basis) of Caribbean small states in 2004 to that in 2006?
Keep it short and to the point. 0.99. What is the ratio of the Pupil-teacher ratio(headcount basis) in Euro area in 2004 to that in 2006?
Make the answer very short. 1.02. What is the ratio of the Pupil-teacher ratio(headcount basis) of Cabo Verde in 2004 to that in 2006?
Offer a terse response. 0.87. What is the ratio of the Pupil-teacher ratio(headcount basis) in Guinea in 2004 to that in 2006?
Provide a short and direct response. 0.89. What is the ratio of the Pupil-teacher ratio(headcount basis) in Euro area in 2004 to that in 2008?
Offer a terse response. 1.02. What is the ratio of the Pupil-teacher ratio(headcount basis) in Cabo Verde in 2004 to that in 2008?
Offer a very short reply. 1.24. What is the ratio of the Pupil-teacher ratio(headcount basis) in Guinea in 2004 to that in 2008?
Offer a terse response. 0.96. What is the ratio of the Pupil-teacher ratio(headcount basis) in Caribbean small states in 2004 to that in 2011?
Provide a short and direct response. 1.09. What is the ratio of the Pupil-teacher ratio(headcount basis) of Cabo Verde in 2004 to that in 2011?
Your answer should be compact. 1.32. What is the ratio of the Pupil-teacher ratio(headcount basis) of Guinea in 2004 to that in 2011?
Your response must be concise. 0.96. What is the ratio of the Pupil-teacher ratio(headcount basis) in Euro area in 2005 to that in 2006?
Ensure brevity in your answer.  0.99. What is the ratio of the Pupil-teacher ratio(headcount basis) in Cabo Verde in 2005 to that in 2006?
Ensure brevity in your answer.  0.9. What is the ratio of the Pupil-teacher ratio(headcount basis) of Guinea in 2005 to that in 2006?
Keep it short and to the point. 0.96. What is the ratio of the Pupil-teacher ratio(headcount basis) of Caribbean small states in 2005 to that in 2008?
Offer a terse response. 1.03. What is the ratio of the Pupil-teacher ratio(headcount basis) in Cabo Verde in 2005 to that in 2008?
Your answer should be very brief. 1.29. What is the ratio of the Pupil-teacher ratio(headcount basis) of Guinea in 2005 to that in 2008?
Your answer should be compact. 1.03. What is the ratio of the Pupil-teacher ratio(headcount basis) of Caribbean small states in 2005 to that in 2011?
Your answer should be very brief. 1.09. What is the ratio of the Pupil-teacher ratio(headcount basis) in Euro area in 2005 to that in 2011?
Offer a very short reply. 0.98. What is the ratio of the Pupil-teacher ratio(headcount basis) of Cabo Verde in 2005 to that in 2011?
Ensure brevity in your answer.  1.37. What is the ratio of the Pupil-teacher ratio(headcount basis) in Guinea in 2005 to that in 2011?
Your answer should be very brief. 1.04. What is the ratio of the Pupil-teacher ratio(headcount basis) of Caribbean small states in 2006 to that in 2008?
Offer a terse response. 1.04. What is the ratio of the Pupil-teacher ratio(headcount basis) in Euro area in 2006 to that in 2008?
Ensure brevity in your answer.  1.01. What is the ratio of the Pupil-teacher ratio(headcount basis) in Cabo Verde in 2006 to that in 2008?
Keep it short and to the point. 1.43. What is the ratio of the Pupil-teacher ratio(headcount basis) in Guinea in 2006 to that in 2008?
Your answer should be compact. 1.08. What is the ratio of the Pupil-teacher ratio(headcount basis) in Caribbean small states in 2006 to that in 2011?
Provide a succinct answer. 1.1. What is the ratio of the Pupil-teacher ratio(headcount basis) in Euro area in 2006 to that in 2011?
Your answer should be compact. 0.98. What is the ratio of the Pupil-teacher ratio(headcount basis) of Cabo Verde in 2006 to that in 2011?
Give a very brief answer. 1.51. What is the ratio of the Pupil-teacher ratio(headcount basis) in Guinea in 2006 to that in 2011?
Your answer should be very brief. 1.08. What is the ratio of the Pupil-teacher ratio(headcount basis) in Caribbean small states in 2008 to that in 2011?
Offer a very short reply. 1.05. What is the ratio of the Pupil-teacher ratio(headcount basis) in Euro area in 2008 to that in 2011?
Make the answer very short. 0.98. What is the ratio of the Pupil-teacher ratio(headcount basis) of Cabo Verde in 2008 to that in 2011?
Offer a terse response. 1.06. What is the ratio of the Pupil-teacher ratio(headcount basis) of Guinea in 2008 to that in 2011?
Your response must be concise. 1. What is the difference between the highest and the second highest Pupil-teacher ratio(headcount basis) in Caribbean small states?
Offer a very short reply. 0.34. What is the difference between the highest and the second highest Pupil-teacher ratio(headcount basis) in Euro area?
Your response must be concise. 0.19. What is the difference between the highest and the second highest Pupil-teacher ratio(headcount basis) in Cabo Verde?
Provide a succinct answer. 2.33. What is the difference between the highest and the second highest Pupil-teacher ratio(headcount basis) of Guinea?
Your answer should be compact. 1.4. What is the difference between the highest and the lowest Pupil-teacher ratio(headcount basis) in Caribbean small states?
Provide a succinct answer. 1.88. What is the difference between the highest and the lowest Pupil-teacher ratio(headcount basis) in Euro area?
Keep it short and to the point. 0.45. What is the difference between the highest and the lowest Pupil-teacher ratio(headcount basis) in Cabo Verde?
Ensure brevity in your answer.  8.79. What is the difference between the highest and the lowest Pupil-teacher ratio(headcount basis) of Guinea?
Make the answer very short. 4.49. 